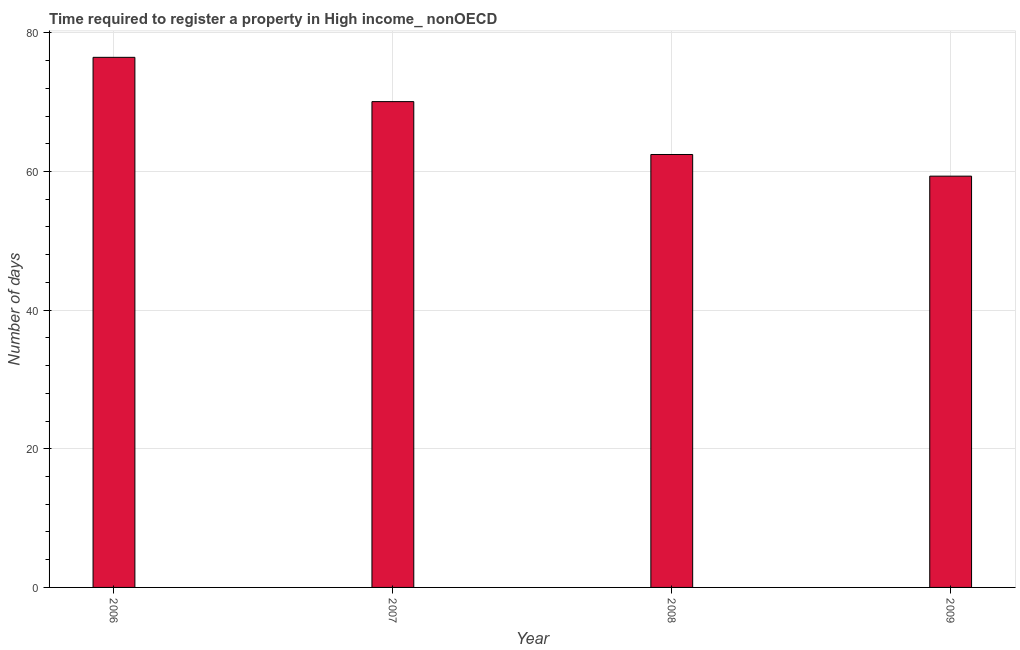Does the graph contain grids?
Offer a very short reply. Yes. What is the title of the graph?
Offer a terse response. Time required to register a property in High income_ nonOECD. What is the label or title of the Y-axis?
Ensure brevity in your answer.  Number of days. What is the number of days required to register property in 2009?
Ensure brevity in your answer.  59.33. Across all years, what is the maximum number of days required to register property?
Provide a short and direct response. 76.47. Across all years, what is the minimum number of days required to register property?
Make the answer very short. 59.33. What is the sum of the number of days required to register property?
Your answer should be very brief. 268.35. What is the difference between the number of days required to register property in 2008 and 2009?
Your answer should be very brief. 3.12. What is the average number of days required to register property per year?
Provide a succinct answer. 67.09. What is the median number of days required to register property?
Your response must be concise. 66.27. Do a majority of the years between 2008 and 2006 (inclusive) have number of days required to register property greater than 76 days?
Offer a very short reply. Yes. What is the ratio of the number of days required to register property in 2006 to that in 2008?
Your answer should be very brief. 1.22. What is the difference between the highest and the second highest number of days required to register property?
Your answer should be very brief. 6.39. What is the difference between the highest and the lowest number of days required to register property?
Provide a short and direct response. 17.14. In how many years, is the number of days required to register property greater than the average number of days required to register property taken over all years?
Your answer should be very brief. 2. What is the difference between two consecutive major ticks on the Y-axis?
Keep it short and to the point. 20. What is the Number of days in 2006?
Make the answer very short. 76.47. What is the Number of days in 2007?
Keep it short and to the point. 70.09. What is the Number of days of 2008?
Keep it short and to the point. 62.46. What is the Number of days of 2009?
Offer a very short reply. 59.33. What is the difference between the Number of days in 2006 and 2007?
Keep it short and to the point. 6.39. What is the difference between the Number of days in 2006 and 2008?
Your answer should be compact. 14.02. What is the difference between the Number of days in 2006 and 2009?
Give a very brief answer. 17.14. What is the difference between the Number of days in 2007 and 2008?
Your response must be concise. 7.63. What is the difference between the Number of days in 2007 and 2009?
Your answer should be compact. 10.75. What is the difference between the Number of days in 2008 and 2009?
Your answer should be very brief. 3.12. What is the ratio of the Number of days in 2006 to that in 2007?
Keep it short and to the point. 1.09. What is the ratio of the Number of days in 2006 to that in 2008?
Your response must be concise. 1.22. What is the ratio of the Number of days in 2006 to that in 2009?
Provide a succinct answer. 1.29. What is the ratio of the Number of days in 2007 to that in 2008?
Provide a short and direct response. 1.12. What is the ratio of the Number of days in 2007 to that in 2009?
Your answer should be compact. 1.18. What is the ratio of the Number of days in 2008 to that in 2009?
Make the answer very short. 1.05. 